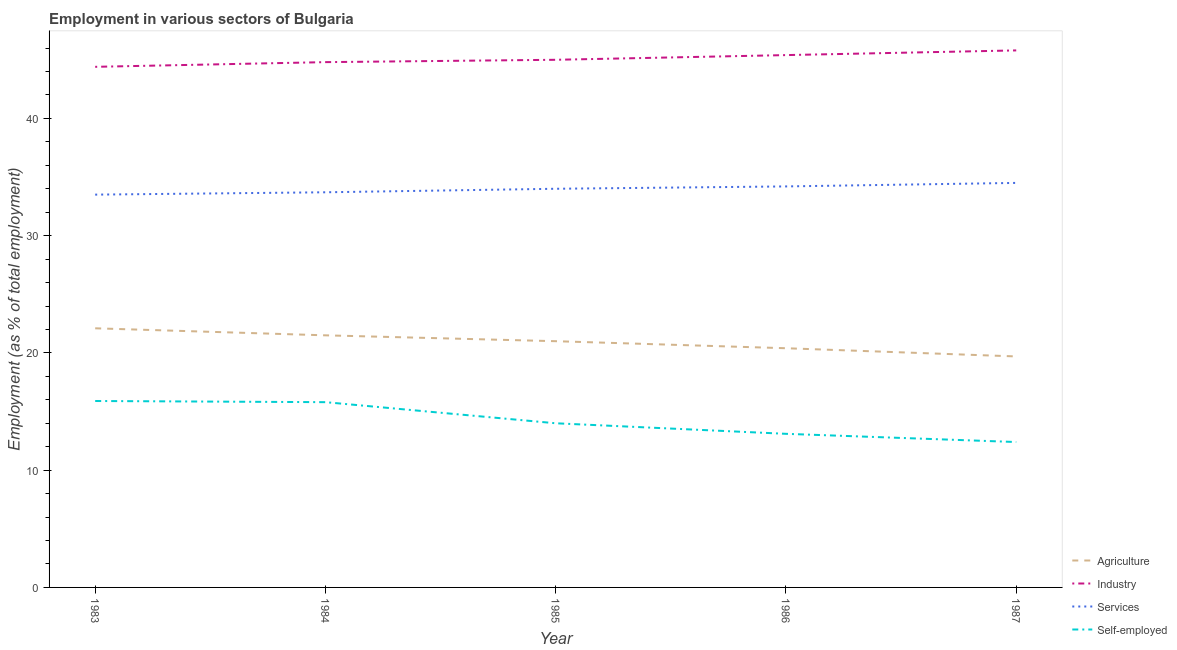How many different coloured lines are there?
Make the answer very short. 4. Does the line corresponding to percentage of workers in agriculture intersect with the line corresponding to percentage of workers in industry?
Provide a succinct answer. No. Is the number of lines equal to the number of legend labels?
Provide a succinct answer. Yes. What is the percentage of workers in industry in 1984?
Give a very brief answer. 44.8. Across all years, what is the maximum percentage of workers in agriculture?
Provide a short and direct response. 22.1. Across all years, what is the minimum percentage of workers in agriculture?
Keep it short and to the point. 19.7. In which year was the percentage of workers in services minimum?
Give a very brief answer. 1983. What is the total percentage of workers in agriculture in the graph?
Provide a short and direct response. 104.7. What is the difference between the percentage of workers in agriculture in 1983 and that in 1987?
Provide a succinct answer. 2.4. What is the difference between the percentage of workers in industry in 1984 and the percentage of workers in services in 1987?
Your answer should be very brief. 10.3. What is the average percentage of self employed workers per year?
Your response must be concise. 14.24. In the year 1984, what is the difference between the percentage of workers in agriculture and percentage of workers in industry?
Give a very brief answer. -23.3. In how many years, is the percentage of self employed workers greater than 42 %?
Offer a very short reply. 0. What is the ratio of the percentage of workers in industry in 1983 to that in 1987?
Give a very brief answer. 0.97. What is the difference between the highest and the second highest percentage of workers in agriculture?
Offer a very short reply. 0.6. What is the difference between the highest and the lowest percentage of workers in industry?
Keep it short and to the point. 1.4. In how many years, is the percentage of workers in agriculture greater than the average percentage of workers in agriculture taken over all years?
Provide a succinct answer. 3. Is it the case that in every year, the sum of the percentage of workers in agriculture and percentage of workers in industry is greater than the sum of percentage of self employed workers and percentage of workers in services?
Your answer should be compact. Yes. Is the percentage of self employed workers strictly greater than the percentage of workers in services over the years?
Your answer should be very brief. No. Is the percentage of workers in agriculture strictly less than the percentage of self employed workers over the years?
Your answer should be compact. No. How many lines are there?
Your answer should be compact. 4. How many years are there in the graph?
Keep it short and to the point. 5. What is the difference between two consecutive major ticks on the Y-axis?
Your response must be concise. 10. Does the graph contain any zero values?
Keep it short and to the point. No. How many legend labels are there?
Provide a short and direct response. 4. How are the legend labels stacked?
Your answer should be very brief. Vertical. What is the title of the graph?
Offer a terse response. Employment in various sectors of Bulgaria. Does "United Kingdom" appear as one of the legend labels in the graph?
Your answer should be very brief. No. What is the label or title of the Y-axis?
Give a very brief answer. Employment (as % of total employment). What is the Employment (as % of total employment) of Agriculture in 1983?
Make the answer very short. 22.1. What is the Employment (as % of total employment) of Industry in 1983?
Your answer should be very brief. 44.4. What is the Employment (as % of total employment) in Services in 1983?
Offer a terse response. 33.5. What is the Employment (as % of total employment) in Self-employed in 1983?
Your response must be concise. 15.9. What is the Employment (as % of total employment) in Industry in 1984?
Provide a short and direct response. 44.8. What is the Employment (as % of total employment) of Services in 1984?
Provide a short and direct response. 33.7. What is the Employment (as % of total employment) in Self-employed in 1984?
Provide a succinct answer. 15.8. What is the Employment (as % of total employment) of Industry in 1985?
Provide a succinct answer. 45. What is the Employment (as % of total employment) in Self-employed in 1985?
Keep it short and to the point. 14. What is the Employment (as % of total employment) in Agriculture in 1986?
Offer a terse response. 20.4. What is the Employment (as % of total employment) of Industry in 1986?
Your answer should be compact. 45.4. What is the Employment (as % of total employment) in Services in 1986?
Your answer should be compact. 34.2. What is the Employment (as % of total employment) of Self-employed in 1986?
Your response must be concise. 13.1. What is the Employment (as % of total employment) in Agriculture in 1987?
Your answer should be very brief. 19.7. What is the Employment (as % of total employment) in Industry in 1987?
Your response must be concise. 45.8. What is the Employment (as % of total employment) of Services in 1987?
Ensure brevity in your answer.  34.5. What is the Employment (as % of total employment) in Self-employed in 1987?
Make the answer very short. 12.4. Across all years, what is the maximum Employment (as % of total employment) of Agriculture?
Offer a terse response. 22.1. Across all years, what is the maximum Employment (as % of total employment) of Industry?
Ensure brevity in your answer.  45.8. Across all years, what is the maximum Employment (as % of total employment) of Services?
Provide a succinct answer. 34.5. Across all years, what is the maximum Employment (as % of total employment) in Self-employed?
Ensure brevity in your answer.  15.9. Across all years, what is the minimum Employment (as % of total employment) in Agriculture?
Make the answer very short. 19.7. Across all years, what is the minimum Employment (as % of total employment) of Industry?
Provide a short and direct response. 44.4. Across all years, what is the minimum Employment (as % of total employment) of Services?
Your response must be concise. 33.5. Across all years, what is the minimum Employment (as % of total employment) in Self-employed?
Your response must be concise. 12.4. What is the total Employment (as % of total employment) in Agriculture in the graph?
Offer a very short reply. 104.7. What is the total Employment (as % of total employment) of Industry in the graph?
Provide a short and direct response. 225.4. What is the total Employment (as % of total employment) of Services in the graph?
Ensure brevity in your answer.  169.9. What is the total Employment (as % of total employment) of Self-employed in the graph?
Ensure brevity in your answer.  71.2. What is the difference between the Employment (as % of total employment) of Industry in 1983 and that in 1985?
Offer a terse response. -0.6. What is the difference between the Employment (as % of total employment) in Services in 1983 and that in 1985?
Offer a very short reply. -0.5. What is the difference between the Employment (as % of total employment) in Self-employed in 1983 and that in 1985?
Your answer should be compact. 1.9. What is the difference between the Employment (as % of total employment) in Agriculture in 1983 and that in 1986?
Your answer should be very brief. 1.7. What is the difference between the Employment (as % of total employment) of Agriculture in 1983 and that in 1987?
Your answer should be compact. 2.4. What is the difference between the Employment (as % of total employment) in Services in 1983 and that in 1987?
Your answer should be compact. -1. What is the difference between the Employment (as % of total employment) of Agriculture in 1984 and that in 1985?
Give a very brief answer. 0.5. What is the difference between the Employment (as % of total employment) of Industry in 1984 and that in 1985?
Keep it short and to the point. -0.2. What is the difference between the Employment (as % of total employment) in Self-employed in 1984 and that in 1985?
Offer a terse response. 1.8. What is the difference between the Employment (as % of total employment) of Self-employed in 1984 and that in 1986?
Keep it short and to the point. 2.7. What is the difference between the Employment (as % of total employment) in Services in 1984 and that in 1987?
Provide a short and direct response. -0.8. What is the difference between the Employment (as % of total employment) in Services in 1985 and that in 1986?
Provide a short and direct response. -0.2. What is the difference between the Employment (as % of total employment) in Agriculture in 1986 and that in 1987?
Your answer should be very brief. 0.7. What is the difference between the Employment (as % of total employment) in Industry in 1986 and that in 1987?
Your answer should be very brief. -0.4. What is the difference between the Employment (as % of total employment) in Services in 1986 and that in 1987?
Offer a very short reply. -0.3. What is the difference between the Employment (as % of total employment) in Self-employed in 1986 and that in 1987?
Your answer should be very brief. 0.7. What is the difference between the Employment (as % of total employment) in Agriculture in 1983 and the Employment (as % of total employment) in Industry in 1984?
Your answer should be compact. -22.7. What is the difference between the Employment (as % of total employment) in Industry in 1983 and the Employment (as % of total employment) in Self-employed in 1984?
Ensure brevity in your answer.  28.6. What is the difference between the Employment (as % of total employment) of Services in 1983 and the Employment (as % of total employment) of Self-employed in 1984?
Offer a very short reply. 17.7. What is the difference between the Employment (as % of total employment) of Agriculture in 1983 and the Employment (as % of total employment) of Industry in 1985?
Keep it short and to the point. -22.9. What is the difference between the Employment (as % of total employment) in Agriculture in 1983 and the Employment (as % of total employment) in Services in 1985?
Your answer should be very brief. -11.9. What is the difference between the Employment (as % of total employment) of Agriculture in 1983 and the Employment (as % of total employment) of Self-employed in 1985?
Your answer should be very brief. 8.1. What is the difference between the Employment (as % of total employment) of Industry in 1983 and the Employment (as % of total employment) of Services in 1985?
Offer a very short reply. 10.4. What is the difference between the Employment (as % of total employment) in Industry in 1983 and the Employment (as % of total employment) in Self-employed in 1985?
Your answer should be very brief. 30.4. What is the difference between the Employment (as % of total employment) in Services in 1983 and the Employment (as % of total employment) in Self-employed in 1985?
Keep it short and to the point. 19.5. What is the difference between the Employment (as % of total employment) of Agriculture in 1983 and the Employment (as % of total employment) of Industry in 1986?
Your response must be concise. -23.3. What is the difference between the Employment (as % of total employment) of Industry in 1983 and the Employment (as % of total employment) of Self-employed in 1986?
Your answer should be very brief. 31.3. What is the difference between the Employment (as % of total employment) in Services in 1983 and the Employment (as % of total employment) in Self-employed in 1986?
Offer a very short reply. 20.4. What is the difference between the Employment (as % of total employment) of Agriculture in 1983 and the Employment (as % of total employment) of Industry in 1987?
Your answer should be compact. -23.7. What is the difference between the Employment (as % of total employment) in Agriculture in 1983 and the Employment (as % of total employment) in Services in 1987?
Offer a terse response. -12.4. What is the difference between the Employment (as % of total employment) of Services in 1983 and the Employment (as % of total employment) of Self-employed in 1987?
Your answer should be very brief. 21.1. What is the difference between the Employment (as % of total employment) of Agriculture in 1984 and the Employment (as % of total employment) of Industry in 1985?
Give a very brief answer. -23.5. What is the difference between the Employment (as % of total employment) in Industry in 1984 and the Employment (as % of total employment) in Self-employed in 1985?
Give a very brief answer. 30.8. What is the difference between the Employment (as % of total employment) in Services in 1984 and the Employment (as % of total employment) in Self-employed in 1985?
Ensure brevity in your answer.  19.7. What is the difference between the Employment (as % of total employment) of Agriculture in 1984 and the Employment (as % of total employment) of Industry in 1986?
Provide a short and direct response. -23.9. What is the difference between the Employment (as % of total employment) of Agriculture in 1984 and the Employment (as % of total employment) of Services in 1986?
Your response must be concise. -12.7. What is the difference between the Employment (as % of total employment) of Industry in 1984 and the Employment (as % of total employment) of Services in 1986?
Offer a very short reply. 10.6. What is the difference between the Employment (as % of total employment) of Industry in 1984 and the Employment (as % of total employment) of Self-employed in 1986?
Your answer should be very brief. 31.7. What is the difference between the Employment (as % of total employment) in Services in 1984 and the Employment (as % of total employment) in Self-employed in 1986?
Offer a very short reply. 20.6. What is the difference between the Employment (as % of total employment) of Agriculture in 1984 and the Employment (as % of total employment) of Industry in 1987?
Your response must be concise. -24.3. What is the difference between the Employment (as % of total employment) of Agriculture in 1984 and the Employment (as % of total employment) of Services in 1987?
Provide a succinct answer. -13. What is the difference between the Employment (as % of total employment) of Agriculture in 1984 and the Employment (as % of total employment) of Self-employed in 1987?
Give a very brief answer. 9.1. What is the difference between the Employment (as % of total employment) in Industry in 1984 and the Employment (as % of total employment) in Self-employed in 1987?
Your answer should be compact. 32.4. What is the difference between the Employment (as % of total employment) in Services in 1984 and the Employment (as % of total employment) in Self-employed in 1987?
Keep it short and to the point. 21.3. What is the difference between the Employment (as % of total employment) in Agriculture in 1985 and the Employment (as % of total employment) in Industry in 1986?
Your answer should be compact. -24.4. What is the difference between the Employment (as % of total employment) in Agriculture in 1985 and the Employment (as % of total employment) in Services in 1986?
Your answer should be compact. -13.2. What is the difference between the Employment (as % of total employment) of Industry in 1985 and the Employment (as % of total employment) of Self-employed in 1986?
Offer a very short reply. 31.9. What is the difference between the Employment (as % of total employment) in Services in 1985 and the Employment (as % of total employment) in Self-employed in 1986?
Keep it short and to the point. 20.9. What is the difference between the Employment (as % of total employment) of Agriculture in 1985 and the Employment (as % of total employment) of Industry in 1987?
Your response must be concise. -24.8. What is the difference between the Employment (as % of total employment) in Agriculture in 1985 and the Employment (as % of total employment) in Self-employed in 1987?
Provide a succinct answer. 8.6. What is the difference between the Employment (as % of total employment) in Industry in 1985 and the Employment (as % of total employment) in Services in 1987?
Keep it short and to the point. 10.5. What is the difference between the Employment (as % of total employment) in Industry in 1985 and the Employment (as % of total employment) in Self-employed in 1987?
Offer a terse response. 32.6. What is the difference between the Employment (as % of total employment) in Services in 1985 and the Employment (as % of total employment) in Self-employed in 1987?
Provide a short and direct response. 21.6. What is the difference between the Employment (as % of total employment) in Agriculture in 1986 and the Employment (as % of total employment) in Industry in 1987?
Keep it short and to the point. -25.4. What is the difference between the Employment (as % of total employment) in Agriculture in 1986 and the Employment (as % of total employment) in Services in 1987?
Make the answer very short. -14.1. What is the difference between the Employment (as % of total employment) in Agriculture in 1986 and the Employment (as % of total employment) in Self-employed in 1987?
Give a very brief answer. 8. What is the difference between the Employment (as % of total employment) in Industry in 1986 and the Employment (as % of total employment) in Services in 1987?
Ensure brevity in your answer.  10.9. What is the difference between the Employment (as % of total employment) in Services in 1986 and the Employment (as % of total employment) in Self-employed in 1987?
Your answer should be very brief. 21.8. What is the average Employment (as % of total employment) of Agriculture per year?
Offer a terse response. 20.94. What is the average Employment (as % of total employment) in Industry per year?
Your answer should be very brief. 45.08. What is the average Employment (as % of total employment) in Services per year?
Keep it short and to the point. 33.98. What is the average Employment (as % of total employment) of Self-employed per year?
Keep it short and to the point. 14.24. In the year 1983, what is the difference between the Employment (as % of total employment) in Agriculture and Employment (as % of total employment) in Industry?
Make the answer very short. -22.3. In the year 1983, what is the difference between the Employment (as % of total employment) in Agriculture and Employment (as % of total employment) in Services?
Keep it short and to the point. -11.4. In the year 1983, what is the difference between the Employment (as % of total employment) in Industry and Employment (as % of total employment) in Services?
Provide a succinct answer. 10.9. In the year 1983, what is the difference between the Employment (as % of total employment) of Services and Employment (as % of total employment) of Self-employed?
Provide a succinct answer. 17.6. In the year 1984, what is the difference between the Employment (as % of total employment) of Agriculture and Employment (as % of total employment) of Industry?
Your answer should be very brief. -23.3. In the year 1984, what is the difference between the Employment (as % of total employment) in Agriculture and Employment (as % of total employment) in Services?
Your response must be concise. -12.2. In the year 1984, what is the difference between the Employment (as % of total employment) of Industry and Employment (as % of total employment) of Services?
Give a very brief answer. 11.1. In the year 1984, what is the difference between the Employment (as % of total employment) in Industry and Employment (as % of total employment) in Self-employed?
Make the answer very short. 29. In the year 1984, what is the difference between the Employment (as % of total employment) in Services and Employment (as % of total employment) in Self-employed?
Offer a terse response. 17.9. In the year 1985, what is the difference between the Employment (as % of total employment) in Industry and Employment (as % of total employment) in Self-employed?
Provide a short and direct response. 31. In the year 1986, what is the difference between the Employment (as % of total employment) of Agriculture and Employment (as % of total employment) of Industry?
Make the answer very short. -25. In the year 1986, what is the difference between the Employment (as % of total employment) of Industry and Employment (as % of total employment) of Services?
Keep it short and to the point. 11.2. In the year 1986, what is the difference between the Employment (as % of total employment) of Industry and Employment (as % of total employment) of Self-employed?
Provide a short and direct response. 32.3. In the year 1986, what is the difference between the Employment (as % of total employment) of Services and Employment (as % of total employment) of Self-employed?
Your answer should be compact. 21.1. In the year 1987, what is the difference between the Employment (as % of total employment) in Agriculture and Employment (as % of total employment) in Industry?
Offer a terse response. -26.1. In the year 1987, what is the difference between the Employment (as % of total employment) in Agriculture and Employment (as % of total employment) in Services?
Keep it short and to the point. -14.8. In the year 1987, what is the difference between the Employment (as % of total employment) in Industry and Employment (as % of total employment) in Services?
Your answer should be very brief. 11.3. In the year 1987, what is the difference between the Employment (as % of total employment) of Industry and Employment (as % of total employment) of Self-employed?
Keep it short and to the point. 33.4. In the year 1987, what is the difference between the Employment (as % of total employment) of Services and Employment (as % of total employment) of Self-employed?
Provide a short and direct response. 22.1. What is the ratio of the Employment (as % of total employment) of Agriculture in 1983 to that in 1984?
Keep it short and to the point. 1.03. What is the ratio of the Employment (as % of total employment) in Industry in 1983 to that in 1984?
Ensure brevity in your answer.  0.99. What is the ratio of the Employment (as % of total employment) in Agriculture in 1983 to that in 1985?
Give a very brief answer. 1.05. What is the ratio of the Employment (as % of total employment) of Industry in 1983 to that in 1985?
Offer a very short reply. 0.99. What is the ratio of the Employment (as % of total employment) in Self-employed in 1983 to that in 1985?
Provide a short and direct response. 1.14. What is the ratio of the Employment (as % of total employment) in Agriculture in 1983 to that in 1986?
Give a very brief answer. 1.08. What is the ratio of the Employment (as % of total employment) in Industry in 1983 to that in 1986?
Keep it short and to the point. 0.98. What is the ratio of the Employment (as % of total employment) in Services in 1983 to that in 1986?
Make the answer very short. 0.98. What is the ratio of the Employment (as % of total employment) of Self-employed in 1983 to that in 1986?
Offer a terse response. 1.21. What is the ratio of the Employment (as % of total employment) in Agriculture in 1983 to that in 1987?
Provide a short and direct response. 1.12. What is the ratio of the Employment (as % of total employment) of Industry in 1983 to that in 1987?
Your response must be concise. 0.97. What is the ratio of the Employment (as % of total employment) in Self-employed in 1983 to that in 1987?
Offer a very short reply. 1.28. What is the ratio of the Employment (as % of total employment) of Agriculture in 1984 to that in 1985?
Provide a short and direct response. 1.02. What is the ratio of the Employment (as % of total employment) in Services in 1984 to that in 1985?
Your answer should be compact. 0.99. What is the ratio of the Employment (as % of total employment) of Self-employed in 1984 to that in 1985?
Give a very brief answer. 1.13. What is the ratio of the Employment (as % of total employment) of Agriculture in 1984 to that in 1986?
Keep it short and to the point. 1.05. What is the ratio of the Employment (as % of total employment) of Industry in 1984 to that in 1986?
Offer a terse response. 0.99. What is the ratio of the Employment (as % of total employment) in Services in 1984 to that in 1986?
Provide a succinct answer. 0.99. What is the ratio of the Employment (as % of total employment) in Self-employed in 1984 to that in 1986?
Provide a short and direct response. 1.21. What is the ratio of the Employment (as % of total employment) in Agriculture in 1984 to that in 1987?
Keep it short and to the point. 1.09. What is the ratio of the Employment (as % of total employment) of Industry in 1984 to that in 1987?
Your answer should be very brief. 0.98. What is the ratio of the Employment (as % of total employment) of Services in 1984 to that in 1987?
Your answer should be very brief. 0.98. What is the ratio of the Employment (as % of total employment) in Self-employed in 1984 to that in 1987?
Provide a short and direct response. 1.27. What is the ratio of the Employment (as % of total employment) in Agriculture in 1985 to that in 1986?
Offer a very short reply. 1.03. What is the ratio of the Employment (as % of total employment) of Services in 1985 to that in 1986?
Make the answer very short. 0.99. What is the ratio of the Employment (as % of total employment) in Self-employed in 1985 to that in 1986?
Offer a terse response. 1.07. What is the ratio of the Employment (as % of total employment) in Agriculture in 1985 to that in 1987?
Your answer should be compact. 1.07. What is the ratio of the Employment (as % of total employment) in Industry in 1985 to that in 1987?
Ensure brevity in your answer.  0.98. What is the ratio of the Employment (as % of total employment) of Services in 1985 to that in 1987?
Your answer should be very brief. 0.99. What is the ratio of the Employment (as % of total employment) in Self-employed in 1985 to that in 1987?
Ensure brevity in your answer.  1.13. What is the ratio of the Employment (as % of total employment) of Agriculture in 1986 to that in 1987?
Ensure brevity in your answer.  1.04. What is the ratio of the Employment (as % of total employment) in Self-employed in 1986 to that in 1987?
Ensure brevity in your answer.  1.06. What is the difference between the highest and the second highest Employment (as % of total employment) in Agriculture?
Make the answer very short. 0.6. What is the difference between the highest and the second highest Employment (as % of total employment) in Industry?
Your answer should be compact. 0.4. What is the difference between the highest and the second highest Employment (as % of total employment) in Services?
Offer a terse response. 0.3. What is the difference between the highest and the lowest Employment (as % of total employment) in Agriculture?
Provide a succinct answer. 2.4. 